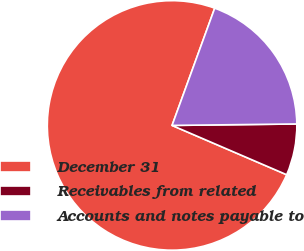<chart> <loc_0><loc_0><loc_500><loc_500><pie_chart><fcel>December 31<fcel>Receivables from related<fcel>Accounts and notes payable to<nl><fcel>74.08%<fcel>6.65%<fcel>19.26%<nl></chart> 